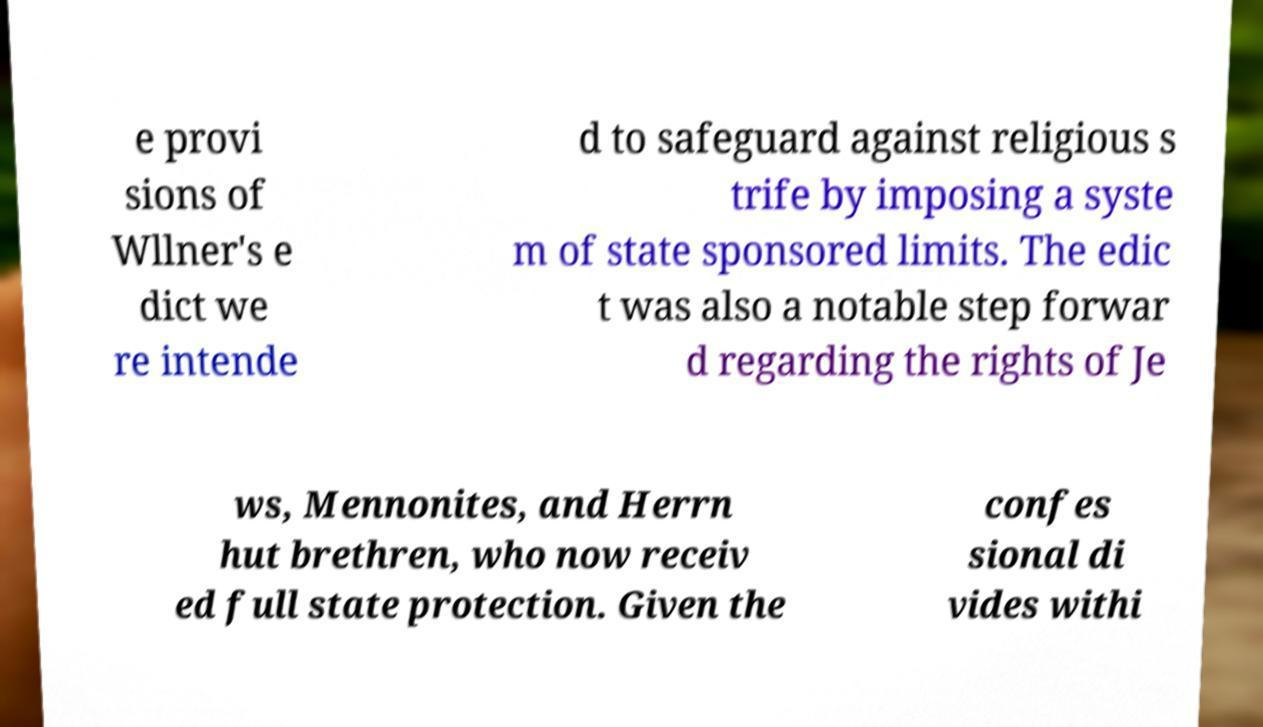Can you read and provide the text displayed in the image?This photo seems to have some interesting text. Can you extract and type it out for me? e provi sions of Wllner's e dict we re intende d to safeguard against religious s trife by imposing a syste m of state sponsored limits. The edic t was also a notable step forwar d regarding the rights of Je ws, Mennonites, and Herrn hut brethren, who now receiv ed full state protection. Given the confes sional di vides withi 